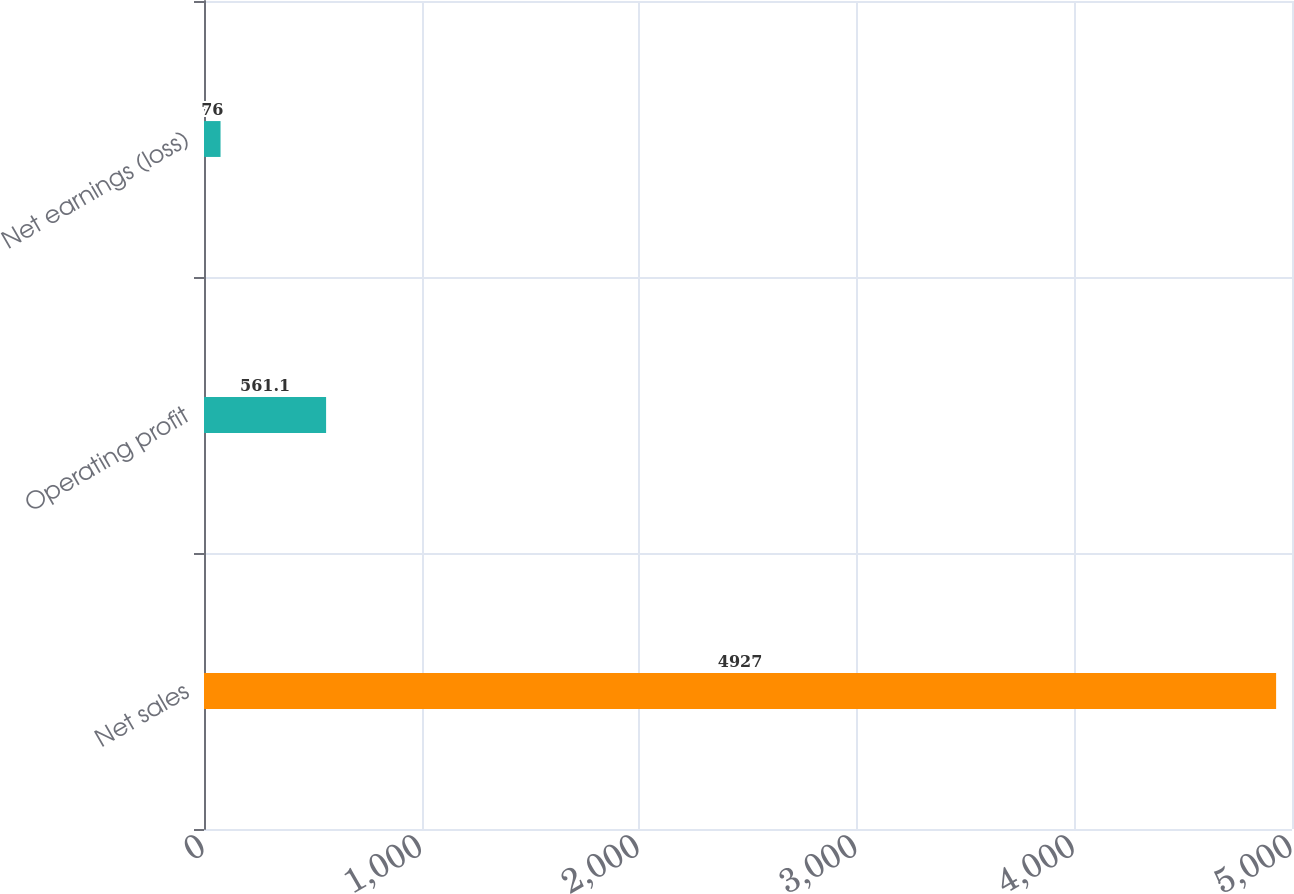Convert chart to OTSL. <chart><loc_0><loc_0><loc_500><loc_500><bar_chart><fcel>Net sales<fcel>Operating profit<fcel>Net earnings (loss)<nl><fcel>4927<fcel>561.1<fcel>76<nl></chart> 